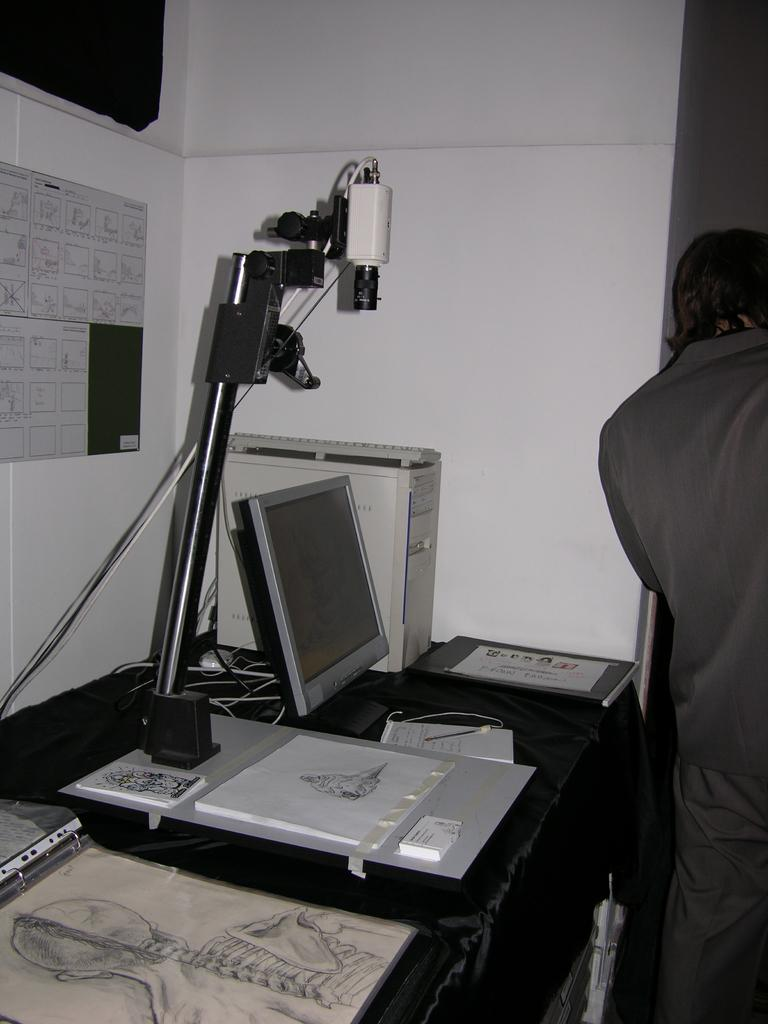What is the main subject of the image? The main subject of the image is a system. What is one of the components of the system? There is a keyboard in the image. What color is one of the objects in the image? There is a white color object in the image. What type of material can be seen on the table? There are papers in the image. Are there any other objects on the table besides the papers? Yes, there are other objects on the table. Can you describe the person standing near the table? There is a person standing near the table. What is on the wall in the image? There is a poster on the wall. How many trees are visible in the image? There are no trees visible in the image. What type of chain is being used to secure the system in the image? There is no chain present in the image. 